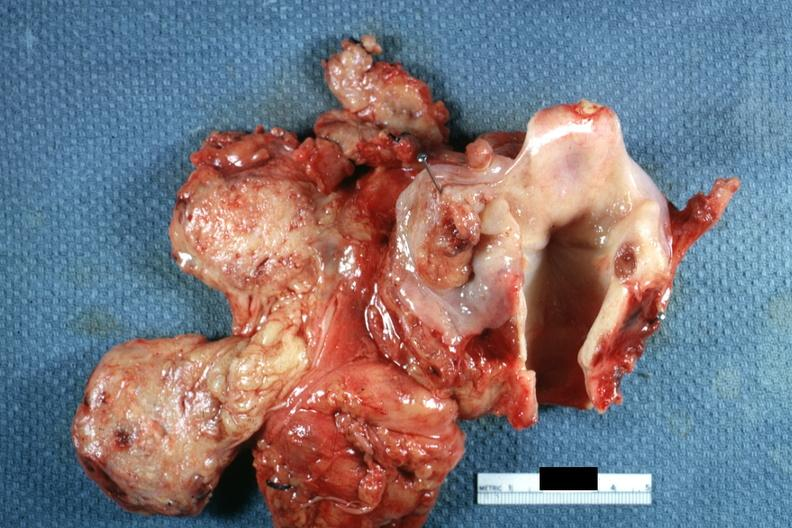does this image show well shown ulcerative lesion in right pyriform sinus?
Answer the question using a single word or phrase. Yes 